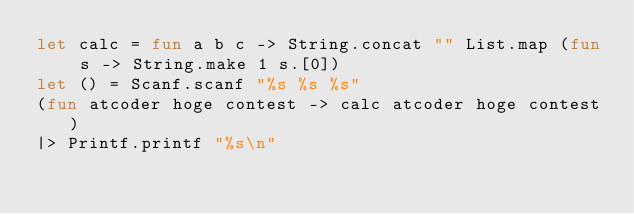<code> <loc_0><loc_0><loc_500><loc_500><_OCaml_>let calc = fun a b c -> String.concat "" List.map (fun s -> String.make 1 s.[0])
let () = Scanf.scanf "%s %s %s"
(fun atcoder hoge contest -> calc atcoder hoge contest)
|> Printf.printf "%s\n"</code> 